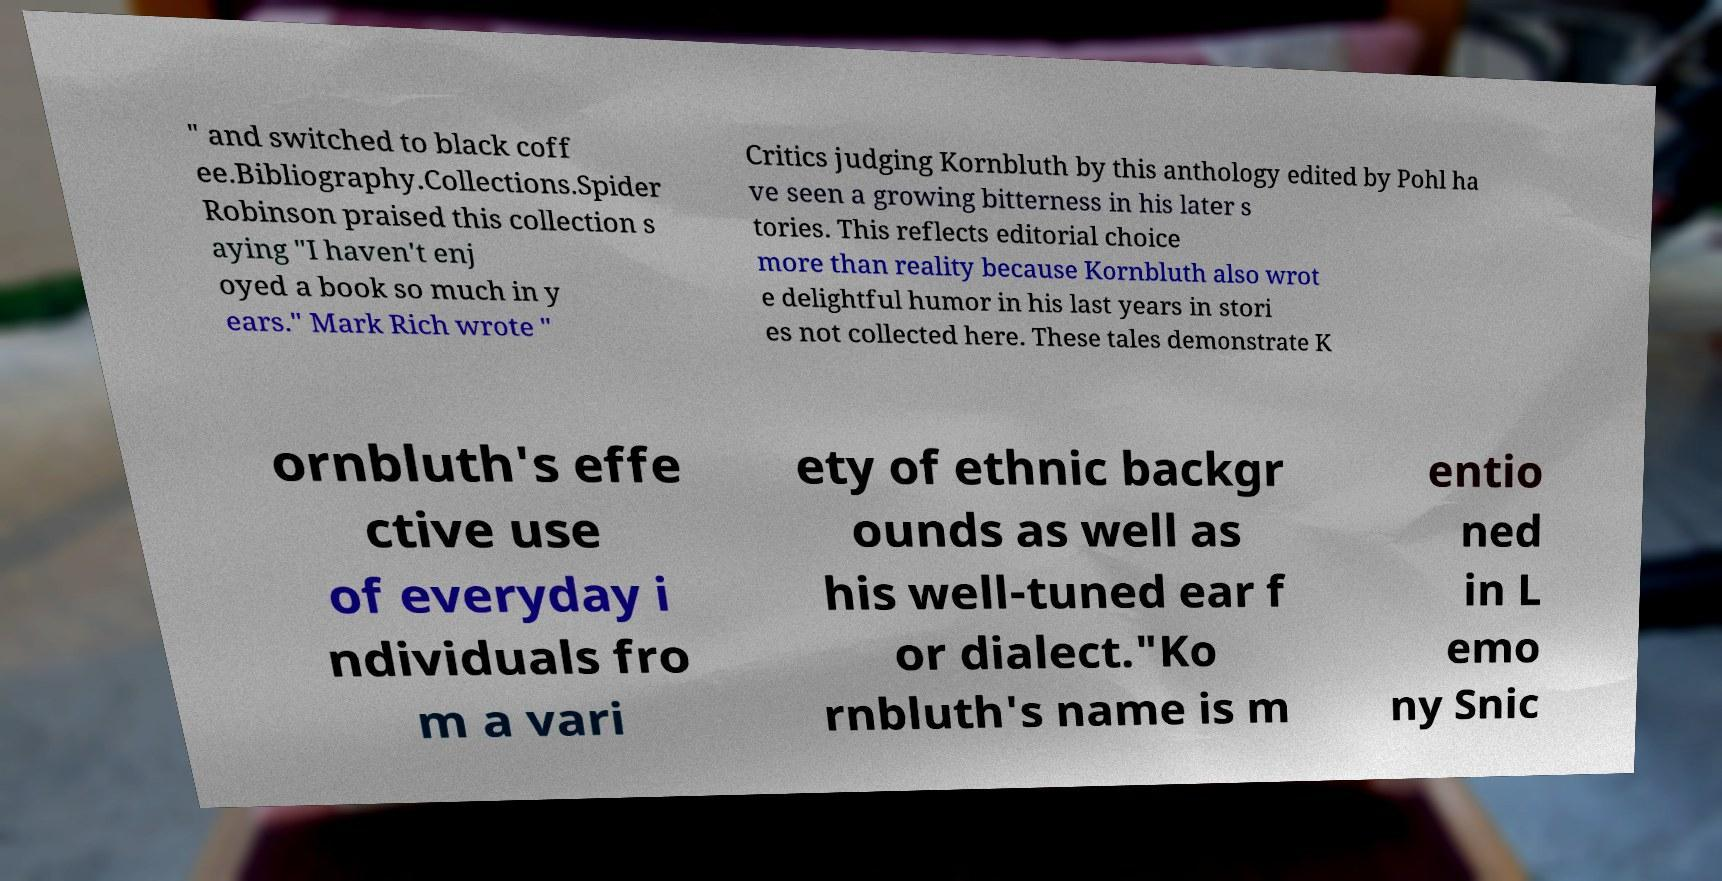Can you read and provide the text displayed in the image?This photo seems to have some interesting text. Can you extract and type it out for me? " and switched to black coff ee.Bibliography.Collections.Spider Robinson praised this collection s aying "I haven't enj oyed a book so much in y ears." Mark Rich wrote " Critics judging Kornbluth by this anthology edited by Pohl ha ve seen a growing bitterness in his later s tories. This reflects editorial choice more than reality because Kornbluth also wrot e delightful humor in his last years in stori es not collected here. These tales demonstrate K ornbluth's effe ctive use of everyday i ndividuals fro m a vari ety of ethnic backgr ounds as well as his well-tuned ear f or dialect."Ko rnbluth's name is m entio ned in L emo ny Snic 